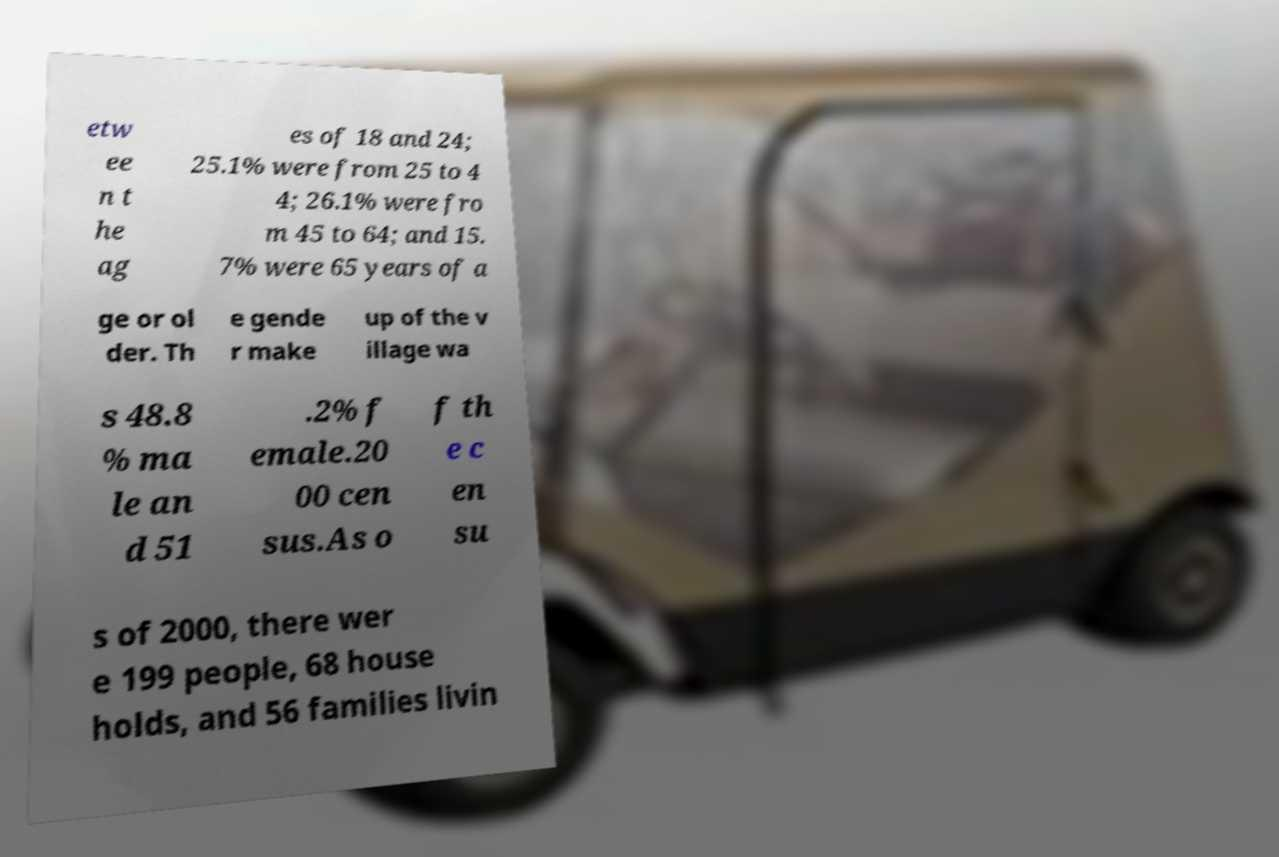There's text embedded in this image that I need extracted. Can you transcribe it verbatim? etw ee n t he ag es of 18 and 24; 25.1% were from 25 to 4 4; 26.1% were fro m 45 to 64; and 15. 7% were 65 years of a ge or ol der. Th e gende r make up of the v illage wa s 48.8 % ma le an d 51 .2% f emale.20 00 cen sus.As o f th e c en su s of 2000, there wer e 199 people, 68 house holds, and 56 families livin 